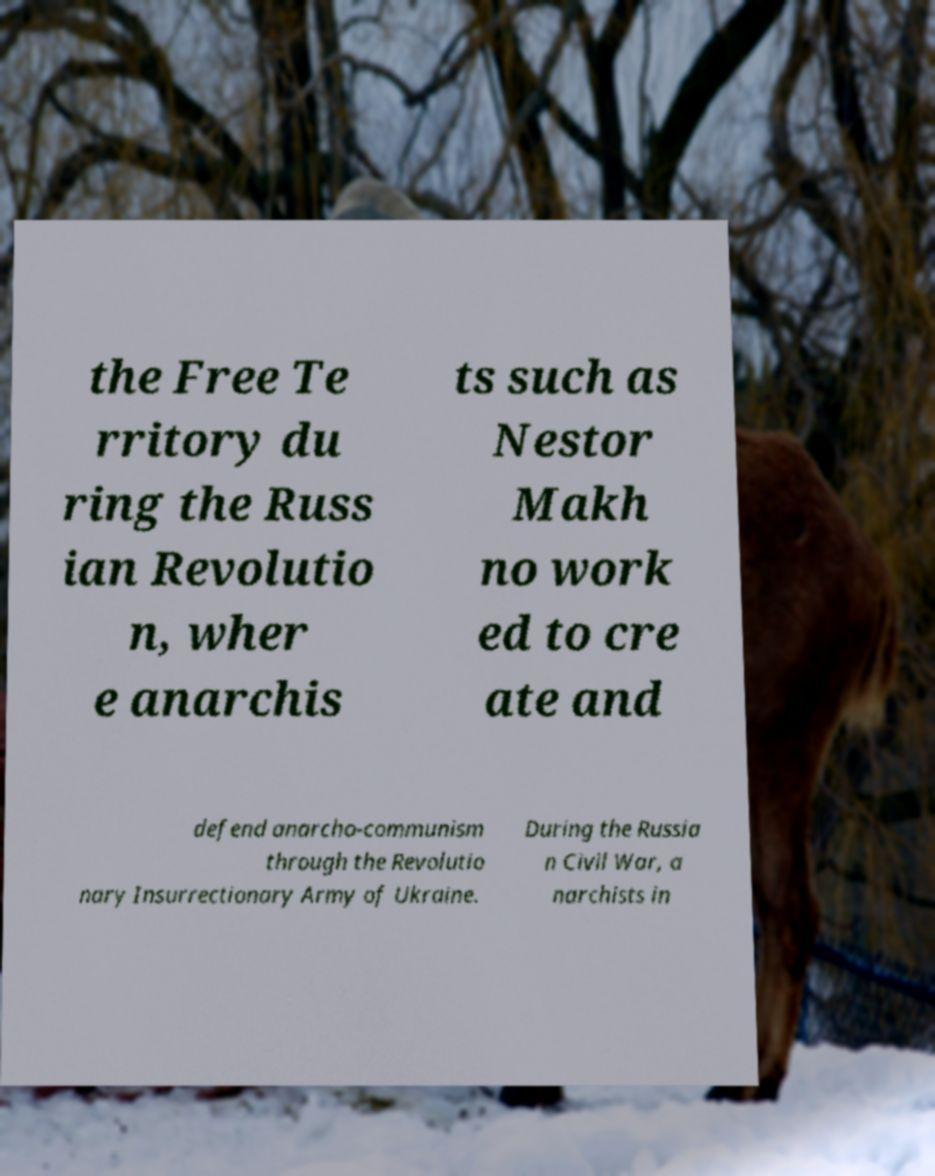There's text embedded in this image that I need extracted. Can you transcribe it verbatim? the Free Te rritory du ring the Russ ian Revolutio n, wher e anarchis ts such as Nestor Makh no work ed to cre ate and defend anarcho-communism through the Revolutio nary Insurrectionary Army of Ukraine. During the Russia n Civil War, a narchists in 